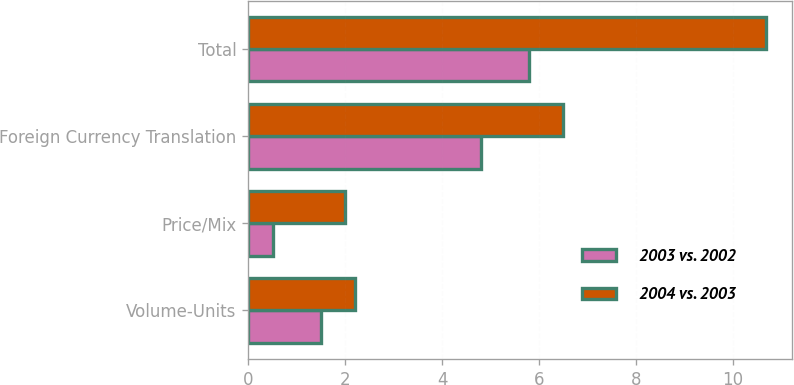Convert chart. <chart><loc_0><loc_0><loc_500><loc_500><stacked_bar_chart><ecel><fcel>Volume-Units<fcel>Price/Mix<fcel>Foreign Currency Translation<fcel>Total<nl><fcel>2003 vs. 2002<fcel>1.5<fcel>0.5<fcel>4.8<fcel>5.8<nl><fcel>2004 vs. 2003<fcel>2.2<fcel>2<fcel>6.5<fcel>10.7<nl></chart> 